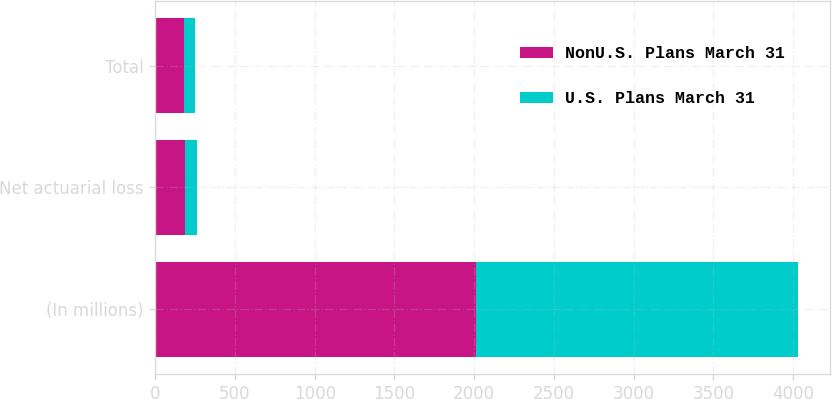Convert chart. <chart><loc_0><loc_0><loc_500><loc_500><stacked_bar_chart><ecel><fcel>(In millions)<fcel>Net actuarial loss<fcel>Total<nl><fcel>NonU.S. Plans March 31<fcel>2014<fcel>188<fcel>181<nl><fcel>U.S. Plans March 31<fcel>2014<fcel>71<fcel>71<nl></chart> 